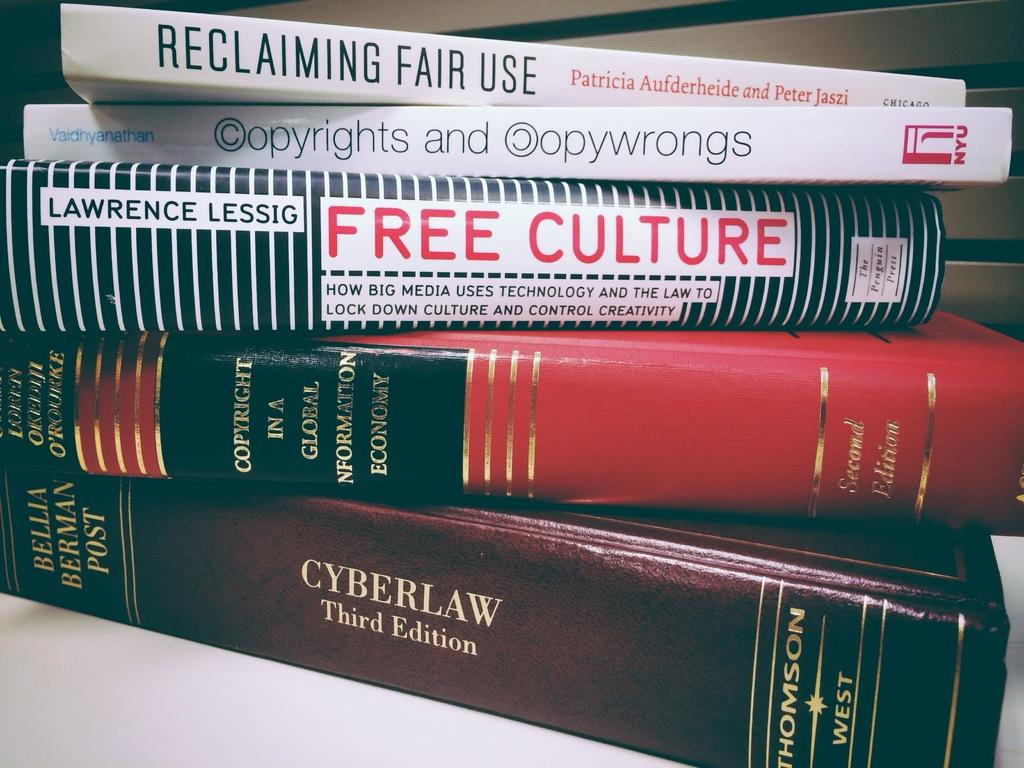Provide a one-sentence caption for the provided image. Five law books concerned with cyber law lie horizontally on top of each other. 